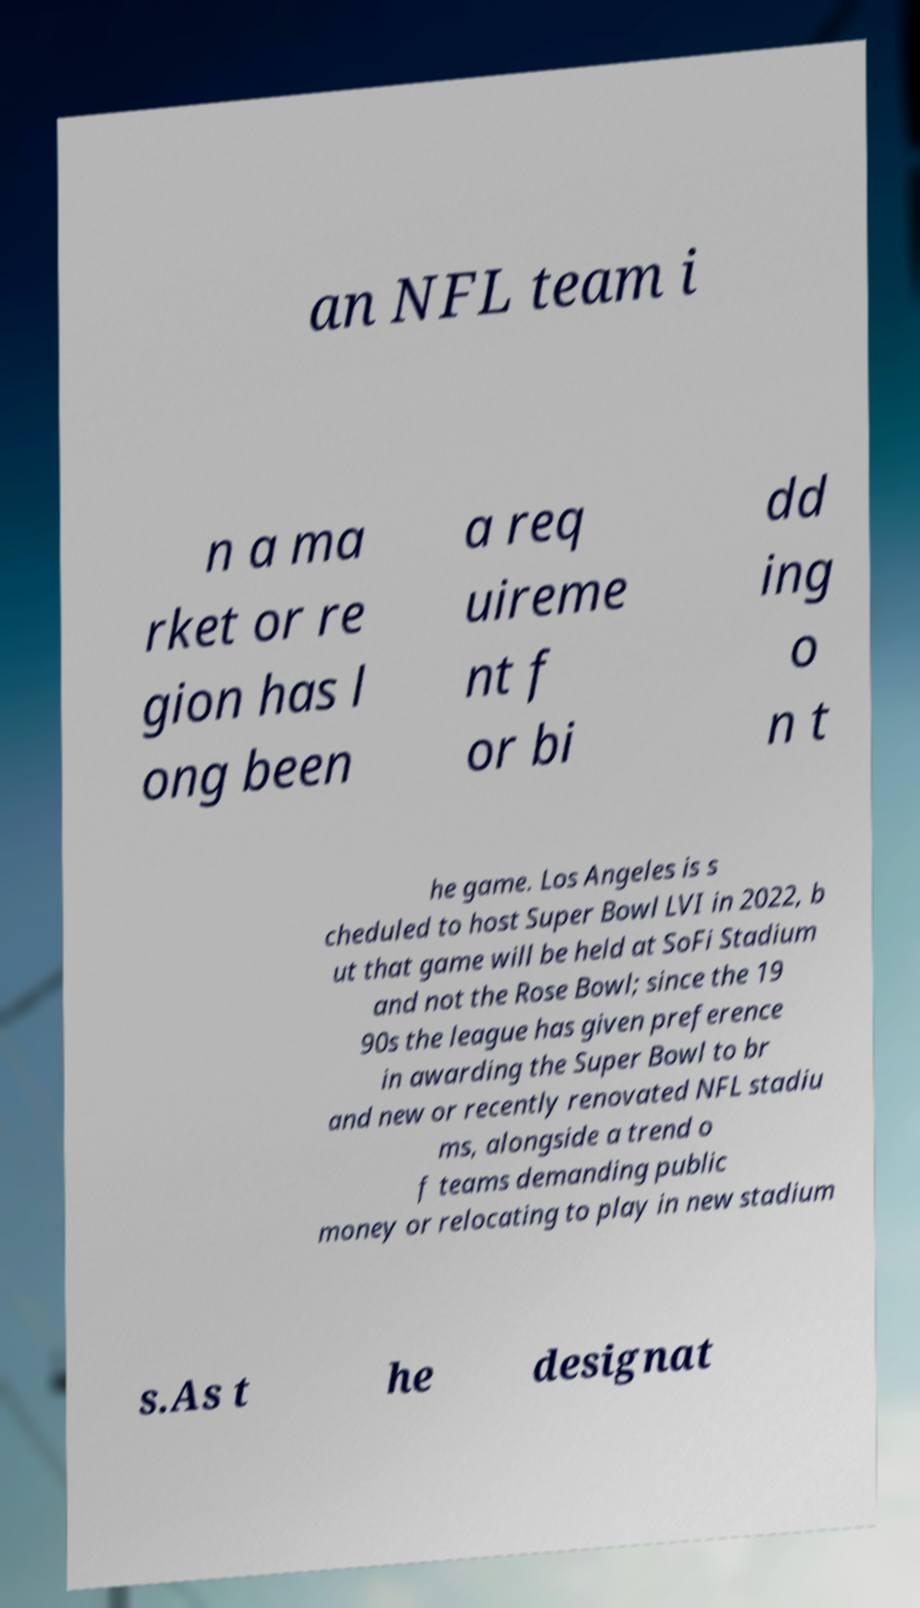I need the written content from this picture converted into text. Can you do that? an NFL team i n a ma rket or re gion has l ong been a req uireme nt f or bi dd ing o n t he game. Los Angeles is s cheduled to host Super Bowl LVI in 2022, b ut that game will be held at SoFi Stadium and not the Rose Bowl; since the 19 90s the league has given preference in awarding the Super Bowl to br and new or recently renovated NFL stadiu ms, alongside a trend o f teams demanding public money or relocating to play in new stadium s.As t he designat 